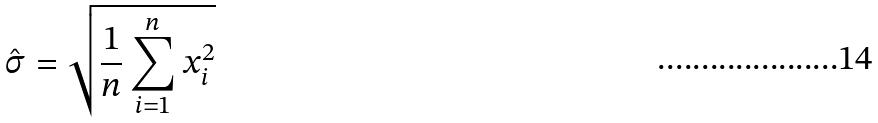<formula> <loc_0><loc_0><loc_500><loc_500>\hat { \sigma } = \sqrt { \frac { 1 } { n } \sum _ { i = 1 } ^ { n } x _ { i } ^ { 2 } }</formula> 